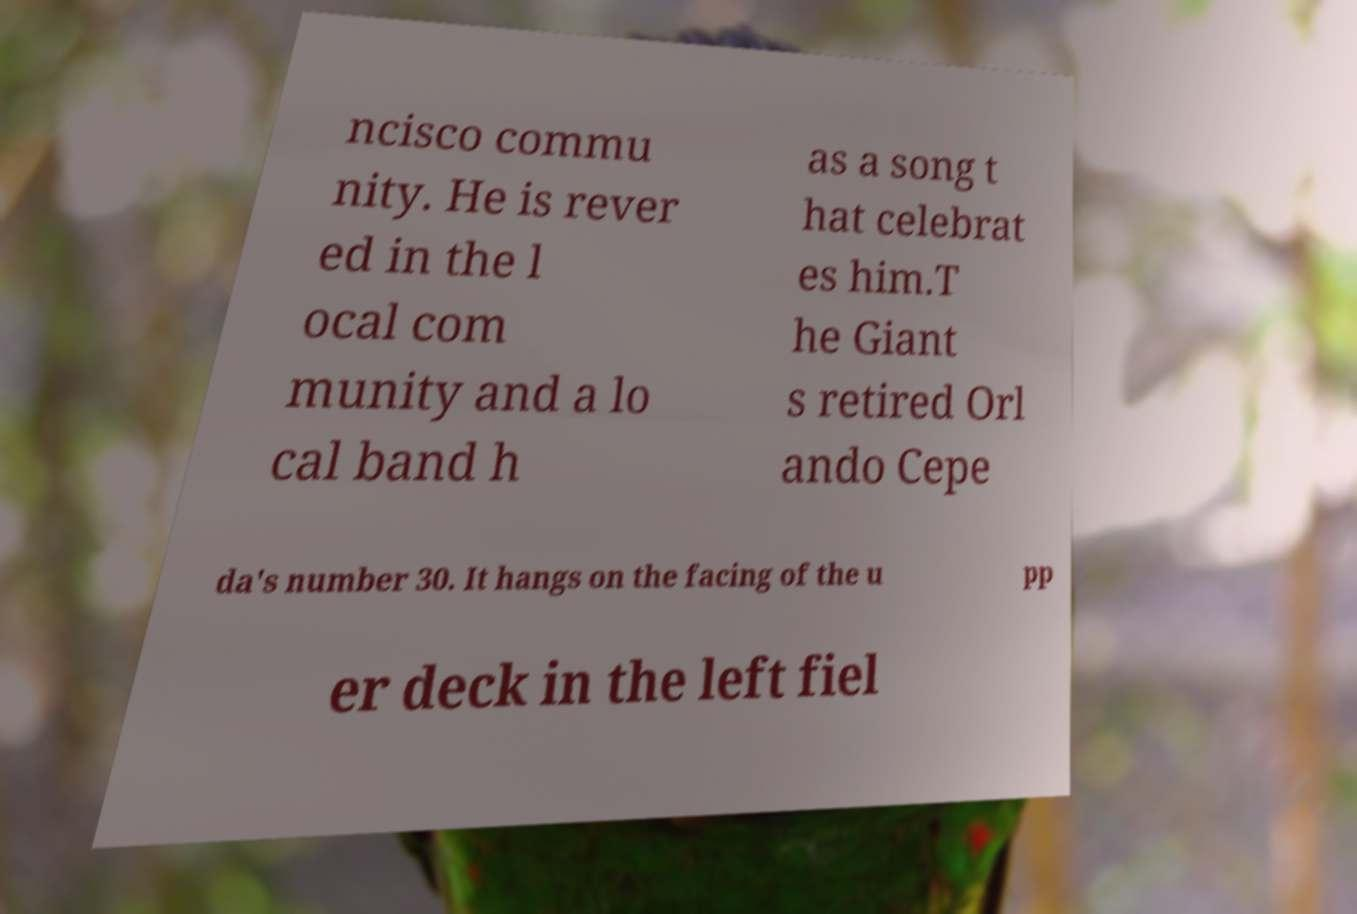Could you assist in decoding the text presented in this image and type it out clearly? ncisco commu nity. He is rever ed in the l ocal com munity and a lo cal band h as a song t hat celebrat es him.T he Giant s retired Orl ando Cepe da's number 30. It hangs on the facing of the u pp er deck in the left fiel 